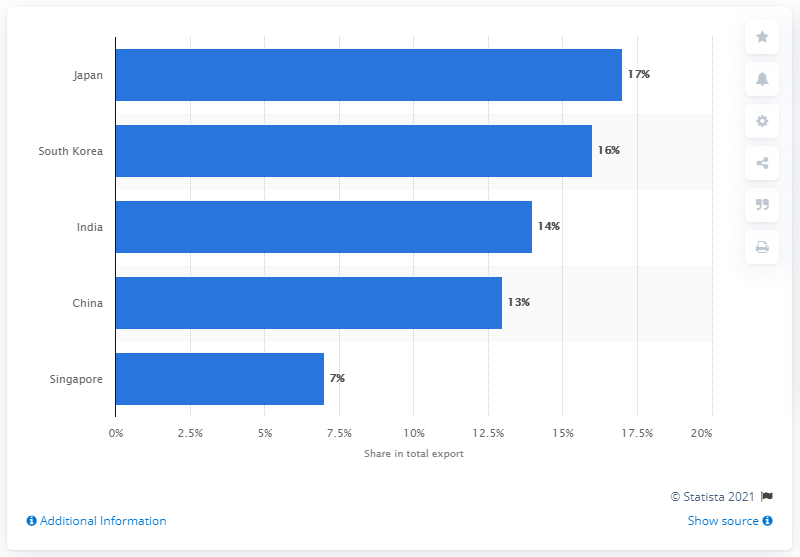Indicate a few pertinent items in this graphic. In 2019, Japan was the most important export partner of Qatar. 